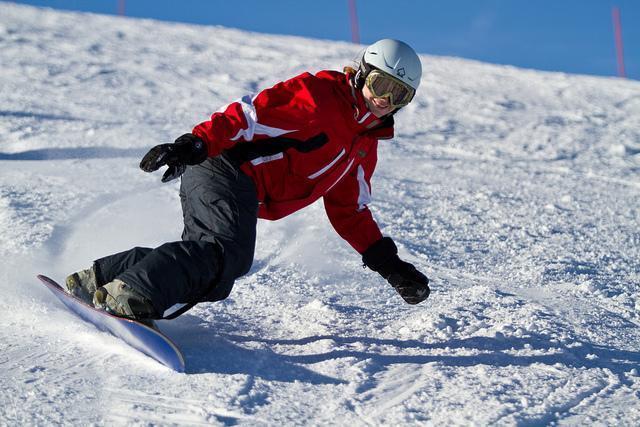How many snowboards are there?
Give a very brief answer. 1. 